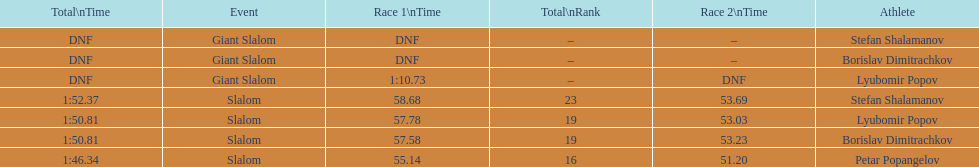What is the difference in time for petar popangelov in race 1and 2 3.94. 